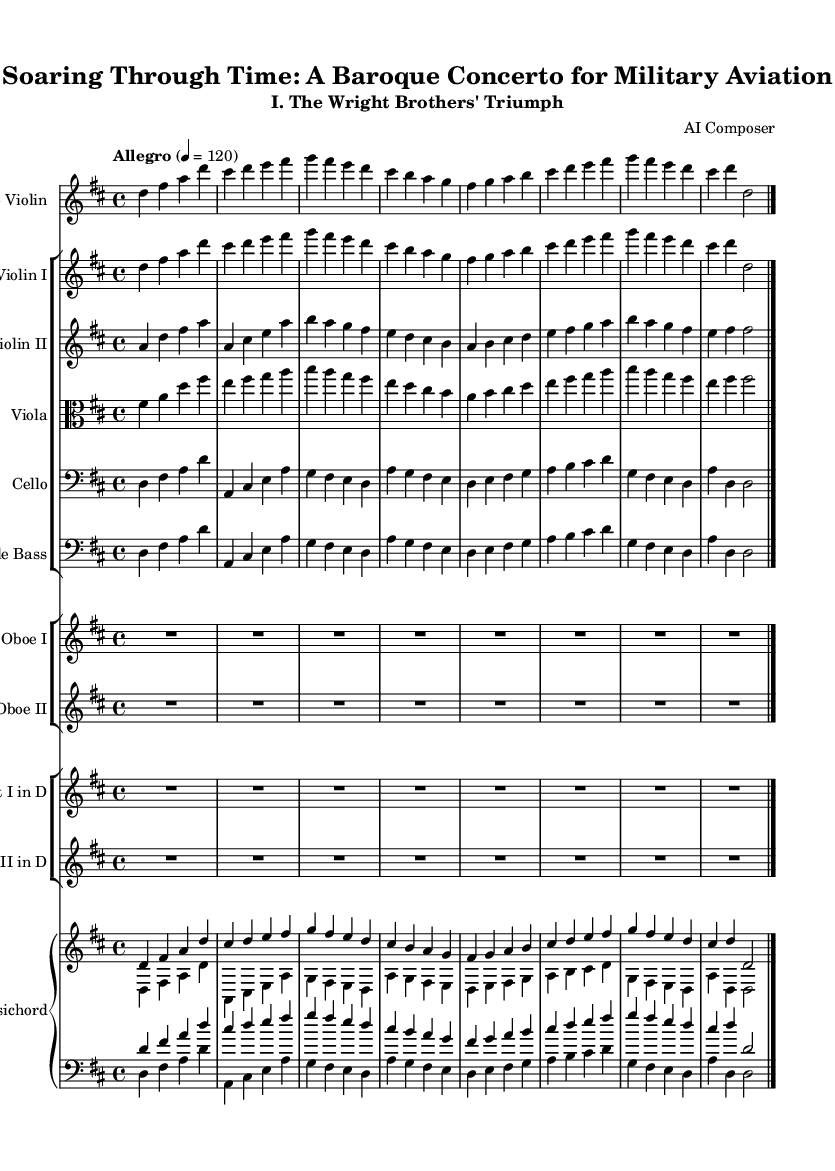What is the key signature of this music? The key signature is D major, which has two sharps (F# and C#). This can be identified in the key signature section at the beginning of the sheet music, where the two sharps are shown on the staff lines.
Answer: D major What is the time signature found in the music? The time signature is 4/4, indicated at the beginning of the piece. This notation shows that there are four beats per measure and that the quarter note receives one beat.
Answer: 4/4 What is the tempo marking for this concerto? The tempo marking is "Allegro," which is a fast tempo. This is specified in the tempo indication that often appears at the start of a piece.
Answer: Allegro How many instruments are featured in this concerto? There are seven types of instruments featured in the concerto: Solo Violin, Violin I, Violin II, Viola, Cello, Double Bass, Oboe I, Oboe II, Trumpet I, Trumpet II, and Harpsichord. This is counted from the staff groups shown in the sheet music.
Answer: Seven What is the subtitle of this piece? The subtitle is "I. The Wright Brothers' Triumph," which is indicated below the main title at the top of the sheet music. This specifies that this movement is themed around the Wright Brothers' contribution to aviation.
Answer: I. The Wright Brothers' Triumph Which instrument plays the solo part in this concerto? The Solo Violin plays the solo part, as indicated by the specific staff labeled "Solo Violin" at the beginning of the score. This instrument carries the main melodic theme throughout the piece.
Answer: Solo Violin 